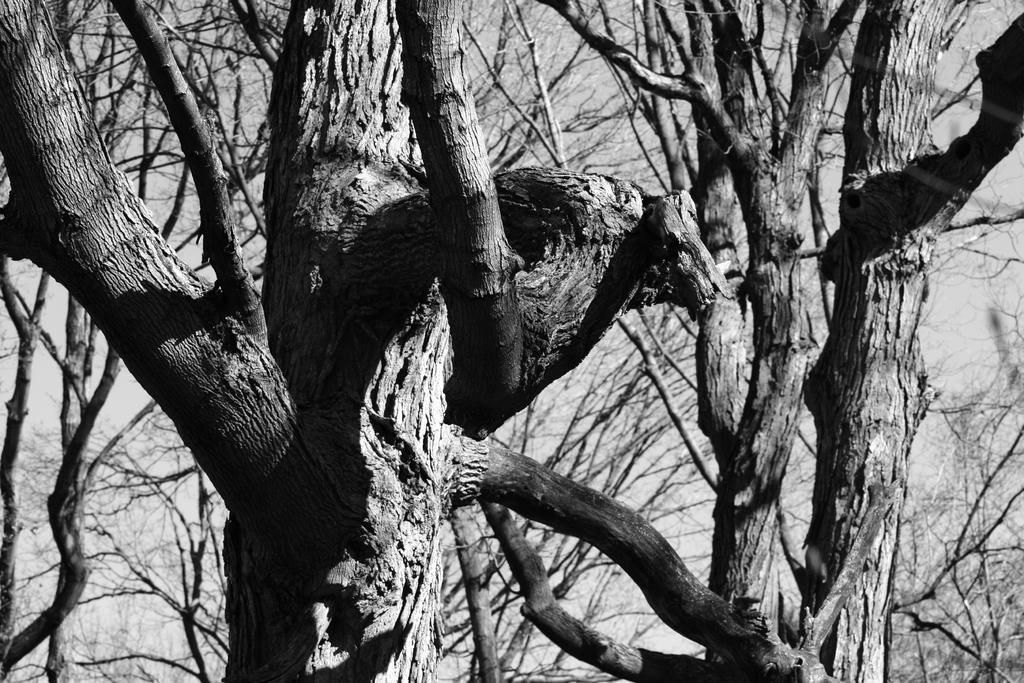What is the color scheme of the image? The image is black and white. What type of natural elements can be seen in the image? There are trees in the image. How many elbows can be seen in the image? There are no elbows present in the image, as it is a black and white image featuring trees. 